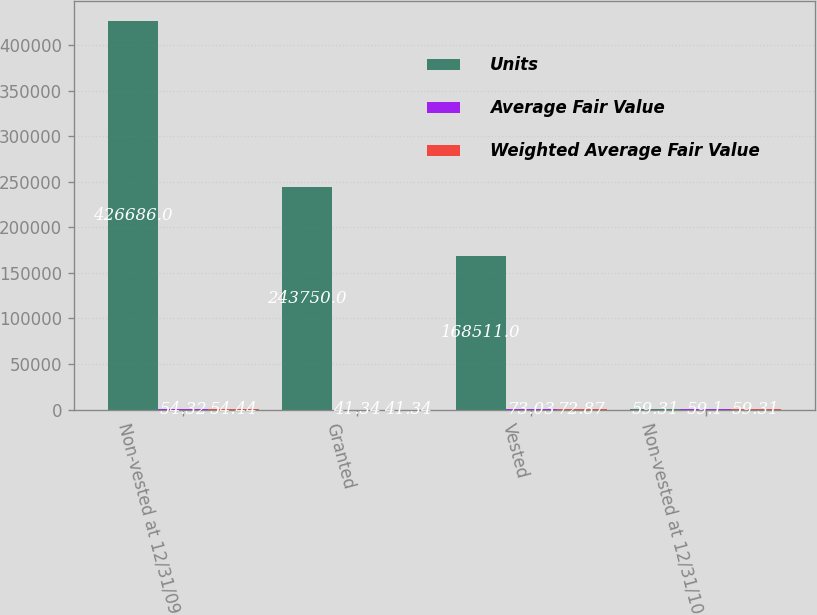Convert chart to OTSL. <chart><loc_0><loc_0><loc_500><loc_500><stacked_bar_chart><ecel><fcel>Non-vested at 12/31/09<fcel>Granted<fcel>Vested<fcel>Non-vested at 12/31/10<nl><fcel>Units<fcel>426686<fcel>243750<fcel>168511<fcel>59.31<nl><fcel>Average Fair Value<fcel>54.32<fcel>41.34<fcel>73.03<fcel>59.1<nl><fcel>Weighted Average Fair Value<fcel>54.44<fcel>41.34<fcel>72.87<fcel>59.31<nl></chart> 